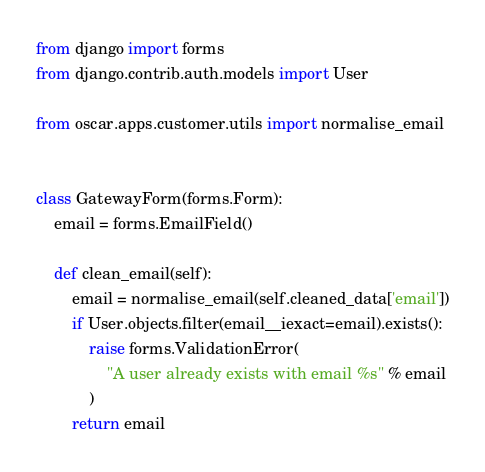<code> <loc_0><loc_0><loc_500><loc_500><_Python_>from django import forms
from django.contrib.auth.models import User

from oscar.apps.customer.utils import normalise_email


class GatewayForm(forms.Form):
    email = forms.EmailField()

    def clean_email(self):
        email = normalise_email(self.cleaned_data['email'])
        if User.objects.filter(email__iexact=email).exists():
            raise forms.ValidationError(
                "A user already exists with email %s" % email
            )
        return email
</code> 